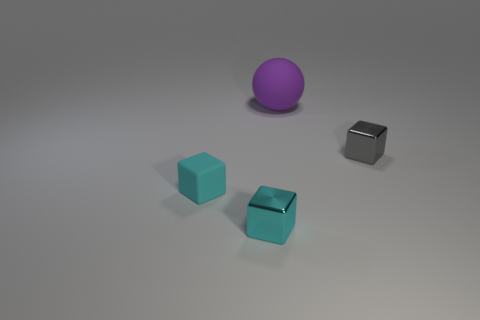Subtract all small cyan rubber blocks. How many blocks are left? 2 Add 4 small gray metallic cylinders. How many objects exist? 8 Subtract all gray cubes. How many cubes are left? 2 Subtract all blocks. How many objects are left? 1 Subtract all cyan cylinders. How many yellow balls are left? 0 Subtract all gray shiny blocks. Subtract all cyan cubes. How many objects are left? 1 Add 3 large purple matte objects. How many large purple matte objects are left? 4 Add 4 big rubber things. How many big rubber things exist? 5 Subtract 0 purple blocks. How many objects are left? 4 Subtract 1 balls. How many balls are left? 0 